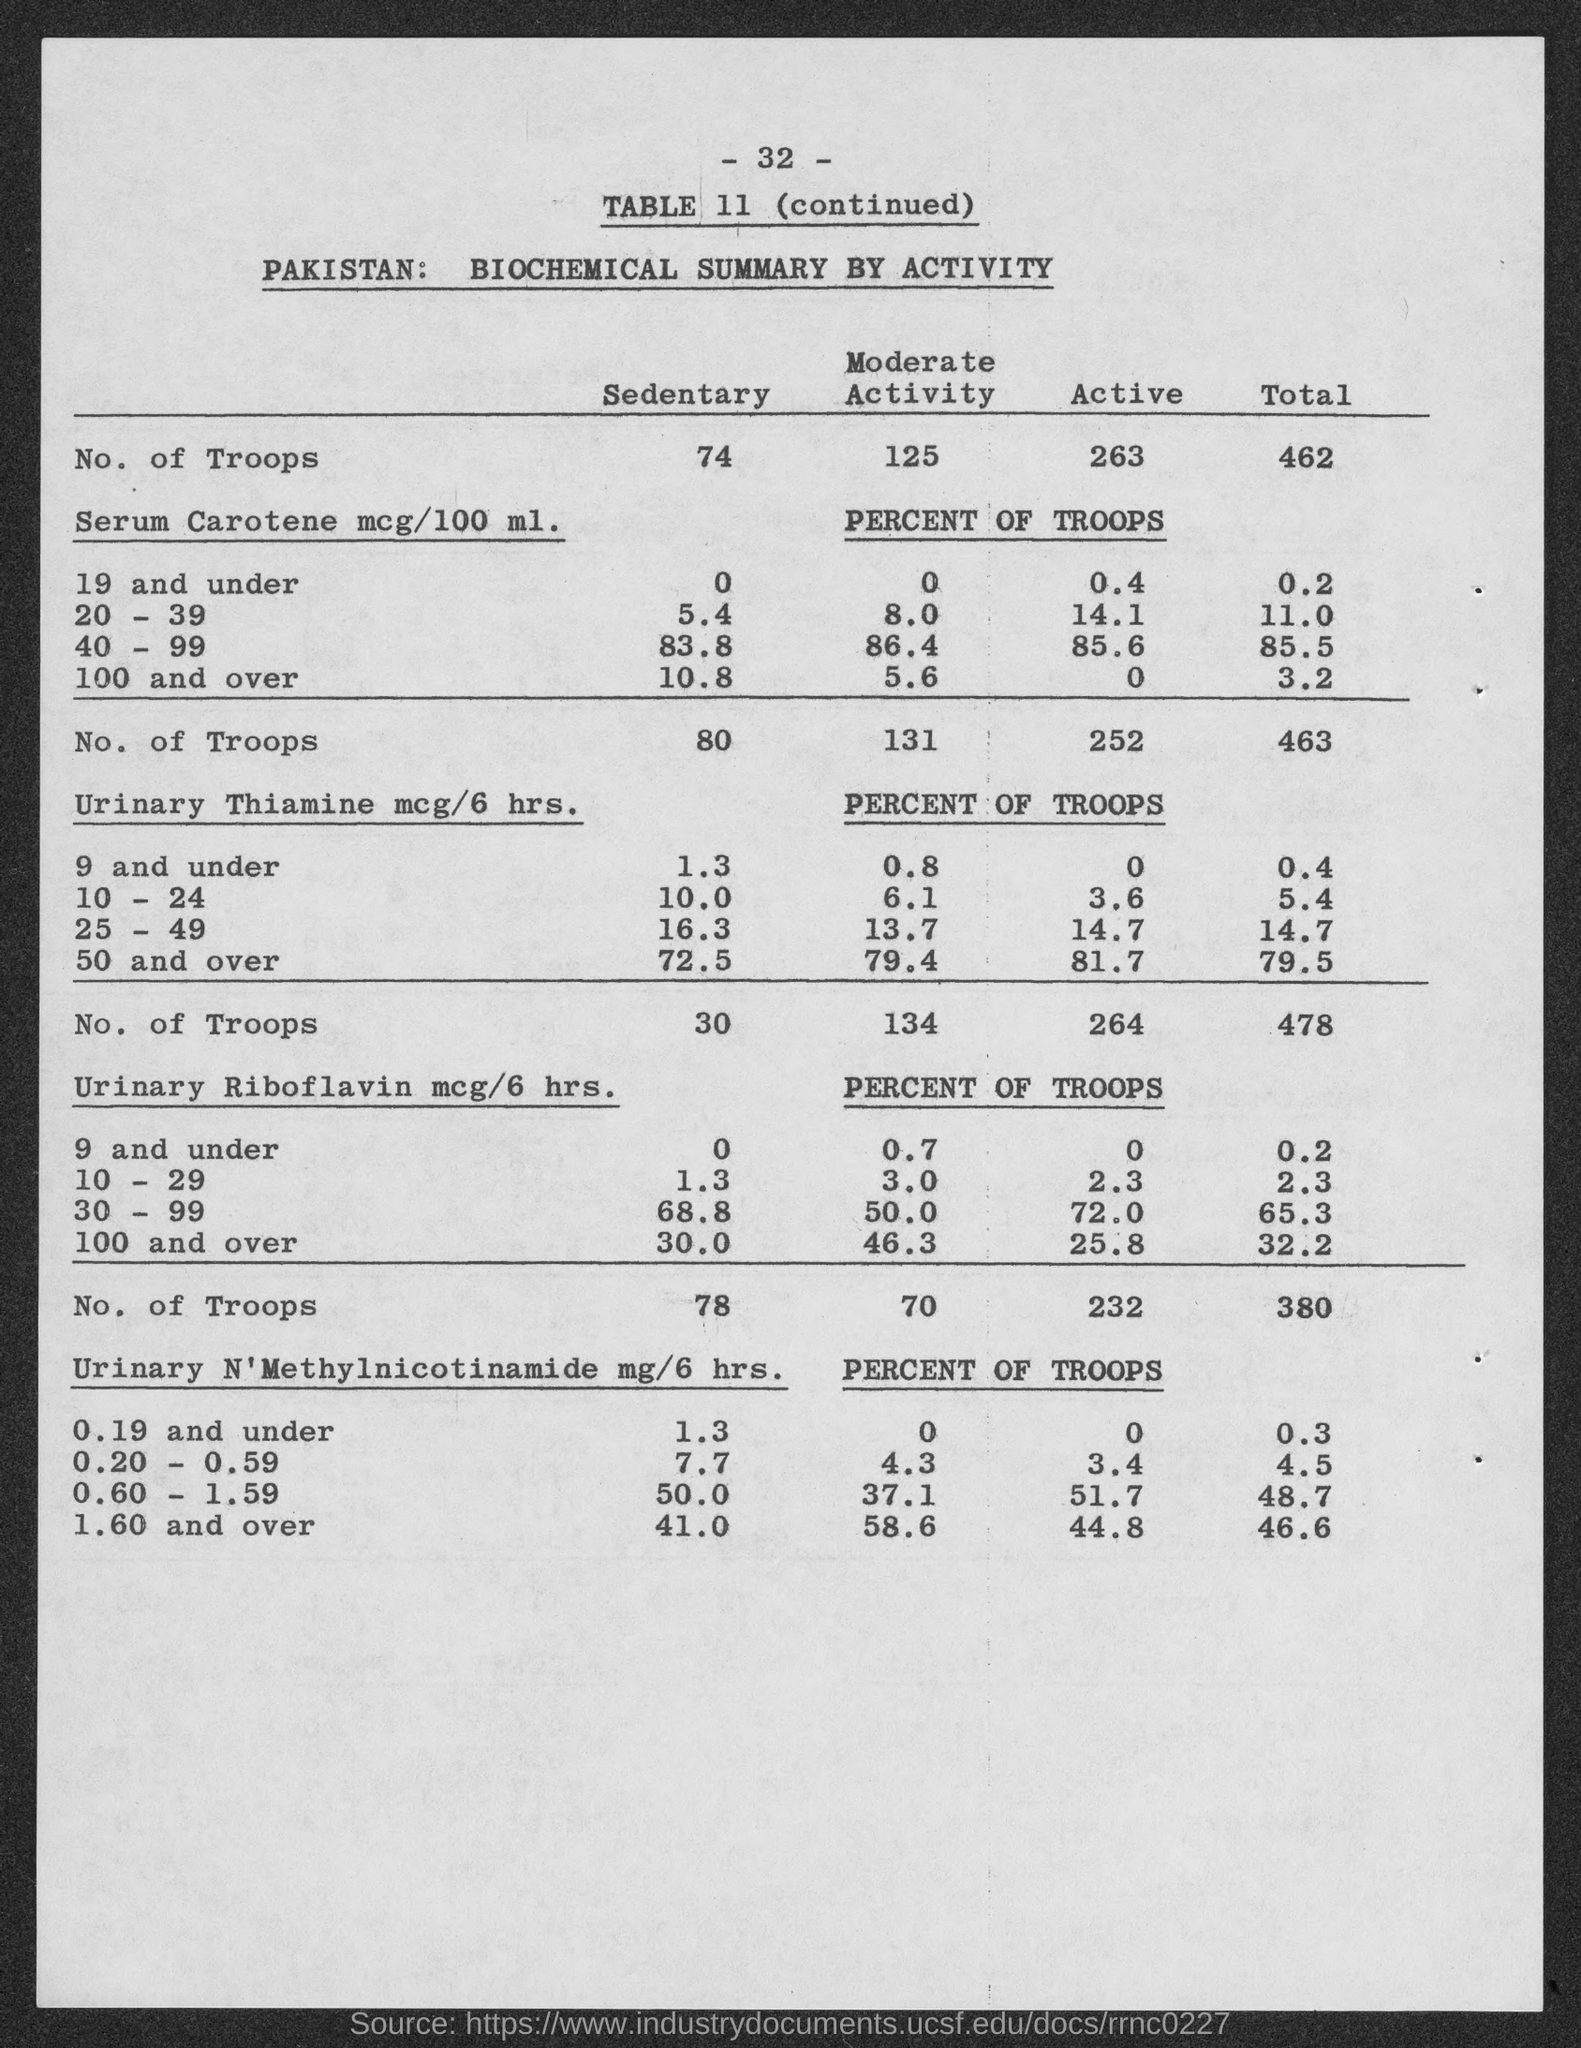What is the number at top of the page?
Your answer should be very brief. -32-. What is the table no.?
Offer a very short reply. 11. 